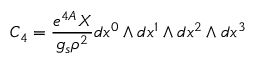<formula> <loc_0><loc_0><loc_500><loc_500>C _ { 4 } = \frac { e ^ { 4 A } X } { g _ { s } \rho ^ { 2 } } d x ^ { 0 } \wedge d x ^ { 1 } \wedge d x ^ { 2 } \wedge d x ^ { 3 }</formula> 